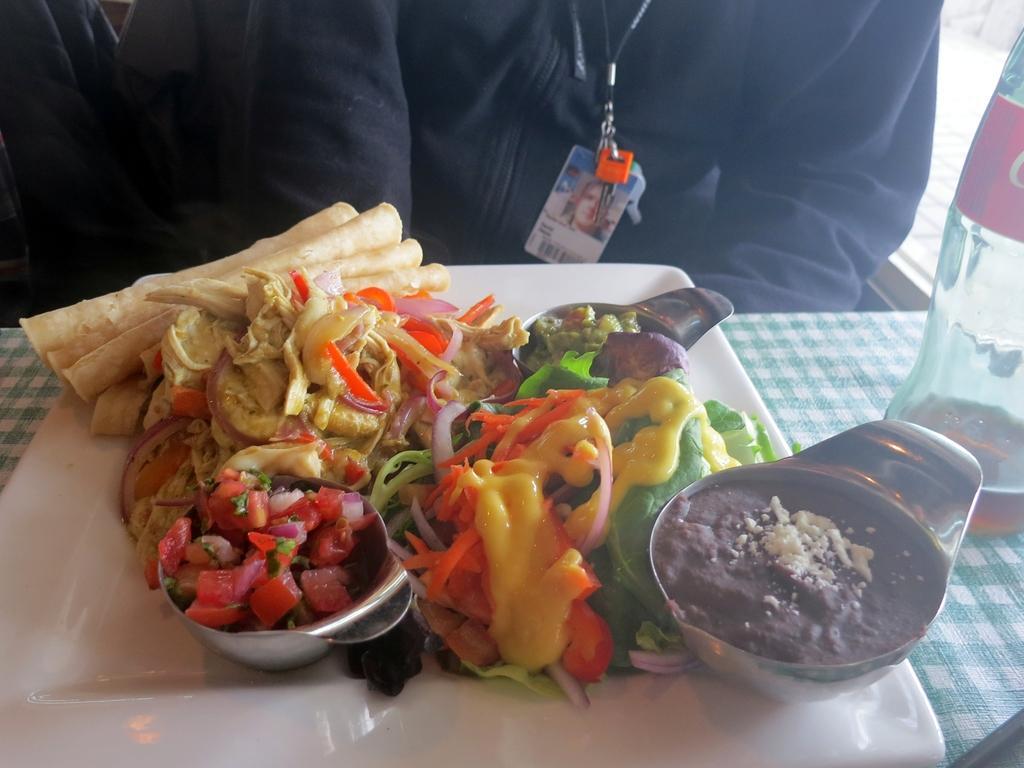How would you summarize this image in a sentence or two? In this picture I can see a person sitting in front of the table on which I can see some food items and bottle are placed. 